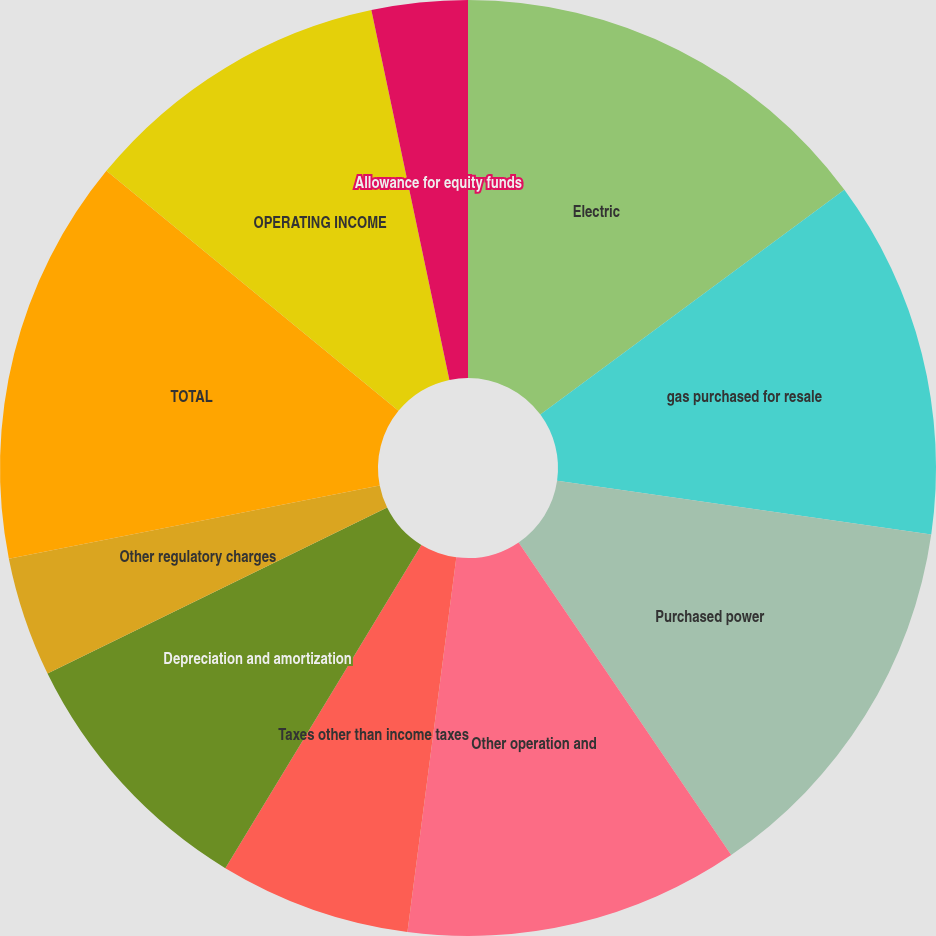Convert chart to OTSL. <chart><loc_0><loc_0><loc_500><loc_500><pie_chart><fcel>Electric<fcel>gas purchased for resale<fcel>Purchased power<fcel>Other operation and<fcel>Taxes other than income taxes<fcel>Depreciation and amortization<fcel>Other regulatory charges<fcel>TOTAL<fcel>OPERATING INCOME<fcel>Allowance for equity funds<nl><fcel>14.87%<fcel>12.4%<fcel>13.22%<fcel>11.57%<fcel>6.61%<fcel>9.09%<fcel>4.13%<fcel>14.05%<fcel>10.74%<fcel>3.31%<nl></chart> 